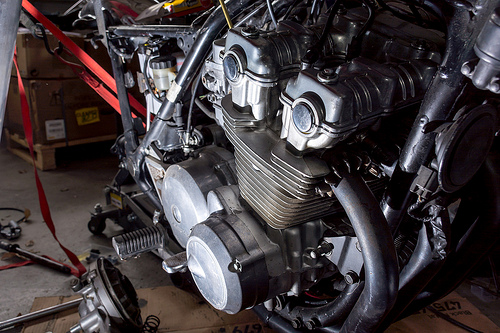<image>
Is the engine behind the fuel tank? No. The engine is not behind the fuel tank. From this viewpoint, the engine appears to be positioned elsewhere in the scene. 